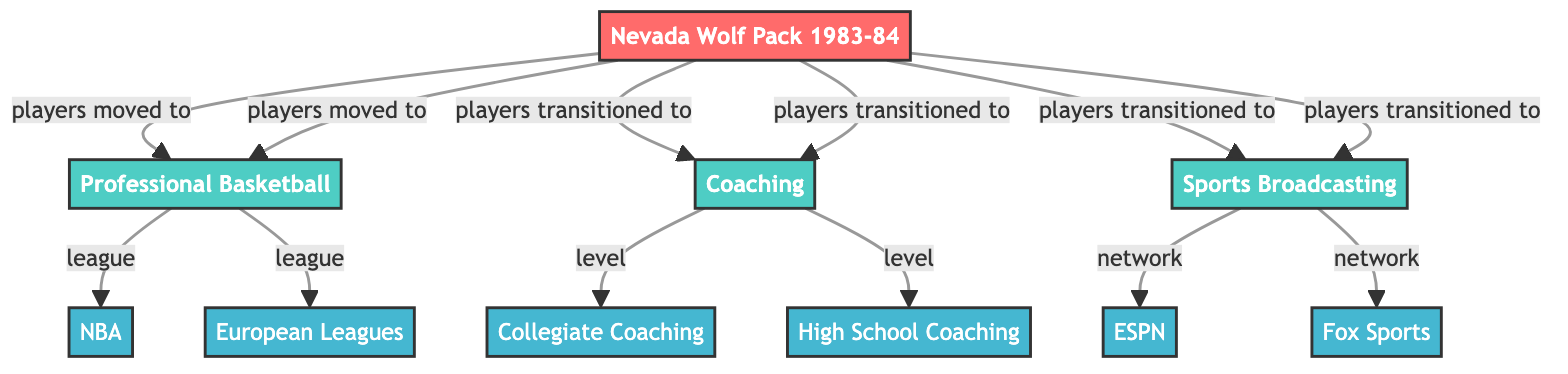What's the total number of nodes in the diagram? The diagram lists a series of different nodes, including teams, career paths, and organizations. Counting them, we find there are 10 nodes in total.
Answer: 10 What is the relationship between Nevada Wolf Pack 1983-84 and Professional Basketball? The edge connects "Nevada Wolf Pack 1983-84" to "Professional Basketball" with the label "players moved to," indicating that players from the Wolf Pack transitioned into professional basketball.
Answer: players moved to Which two leagues are linked to Professional Basketball in the diagram? The edges connected to "Professional Basketball" lead to two organizations labeled "NBA" and "European Leagues," indicating these are the leagues where players may be involved.
Answer: NBA, European Leagues What type of career paths do players from Nevada Wolf Pack 1983-84 transition into? The diagram shows edges leading from "Nevada Wolf Pack 1983-84" to both "Coaching" and "Sports Broadcasting," which are the career paths players can take after their time at the Wolf Pack.
Answer: Coaching, Sports Broadcasting How many levels of coaching are depicted in the diagram? The diagram contains two specific nodes under "Coaching" labeled "Collegiate Coaching" and "High School Coaching." This indicates that there are two different levels of coaching paths available.
Answer: 2 Which organizations are associated with Sports Broadcasting in the diagram? From the "Sports Broadcasting" node, there are two edges leading to nodes labeled "ESPN" and "Fox Sports." This indicates that these are the networks associated with sports broadcasting for players who transitioned to this career.
Answer: ESPN, Fox Sports What career path is shown to have a direct link to collegiate coaching? The edge from "Coaching" to "Collegiate Coaching" indicates that collegiate coaching is a specific level of the broader coaching career path, thus showing that collegiate coaching is directly linked to coaching.
Answer: Collegiate Coaching Which node represents the team from which career paths originate? The node labeled "Nevada Wolf Pack 1983-84" is the starting point that connects to various career paths in the diagram, serving as the origin for many of the players' transitions.
Answer: Nevada Wolf Pack 1983-84 What type of organization is depicted under the node 'Professional Basketball'? The diagram shows that the edges from "Professional Basketball" connect to organizations which are types of leagues, specifically "NBA" and "European Leagues." Therefore, these organizations represent the leagues associated with professional basketball.
Answer: organization 